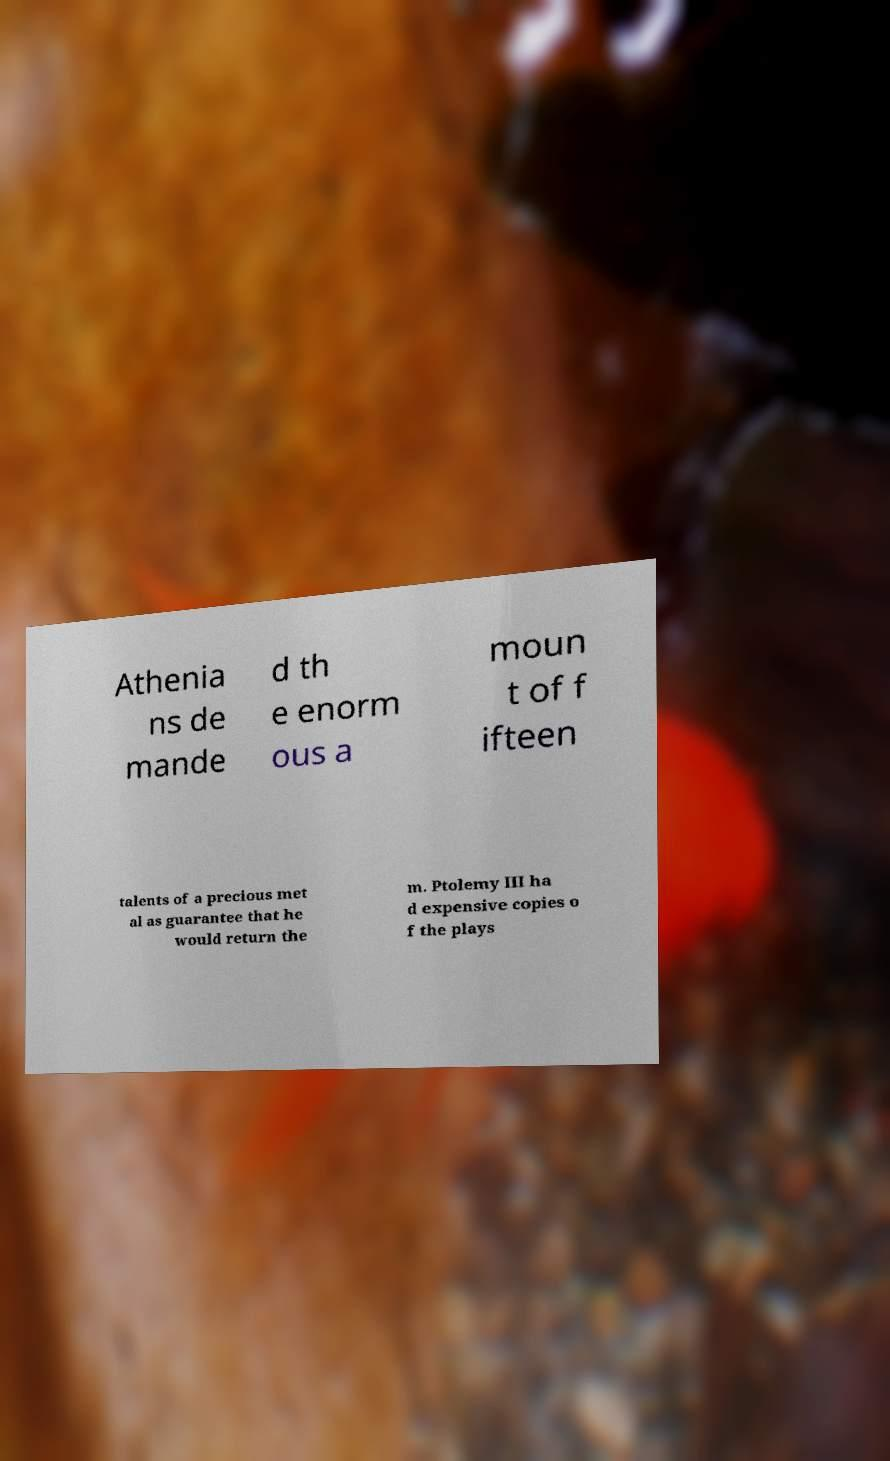Please read and relay the text visible in this image. What does it say? Athenia ns de mande d th e enorm ous a moun t of f ifteen talents of a precious met al as guarantee that he would return the m. Ptolemy III ha d expensive copies o f the plays 